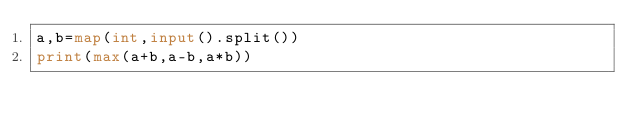Convert code to text. <code><loc_0><loc_0><loc_500><loc_500><_Python_>a,b=map(int,input().split())
print(max(a+b,a-b,a*b))</code> 